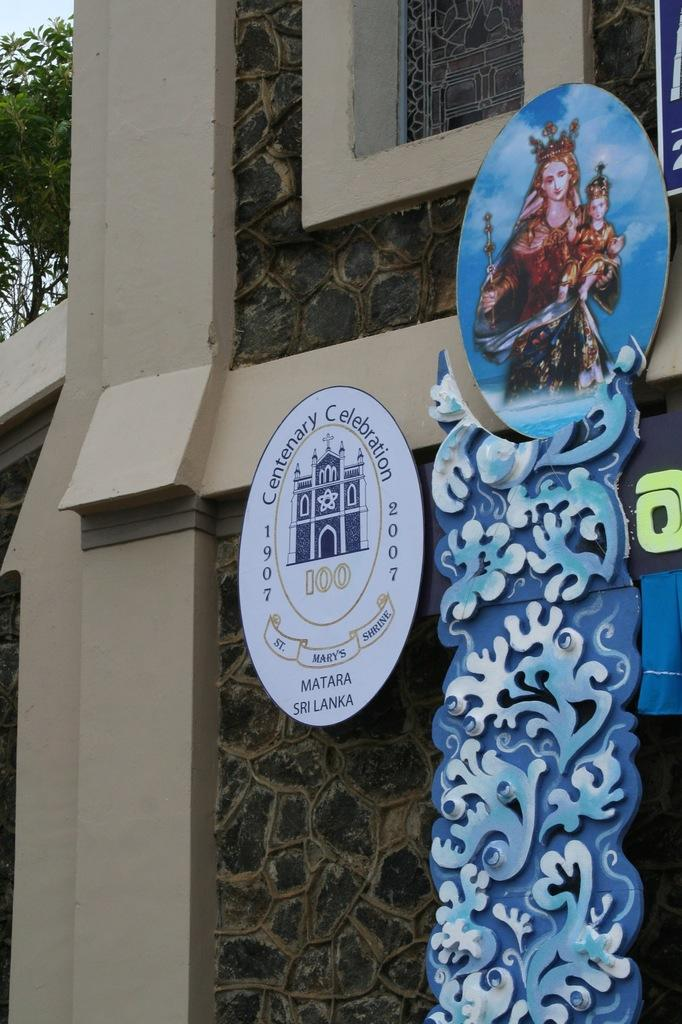What structure is the main subject of the image? There is a building in the image. What is placed on the building? Boards are placed on the building. What can be seen in the background of the image? There is a tree and the sky visible in the background of the image. What rule is being enforced by the tree in the image? There is no rule being enforced by the tree in the image, as trees do not have the ability to enforce rules. 